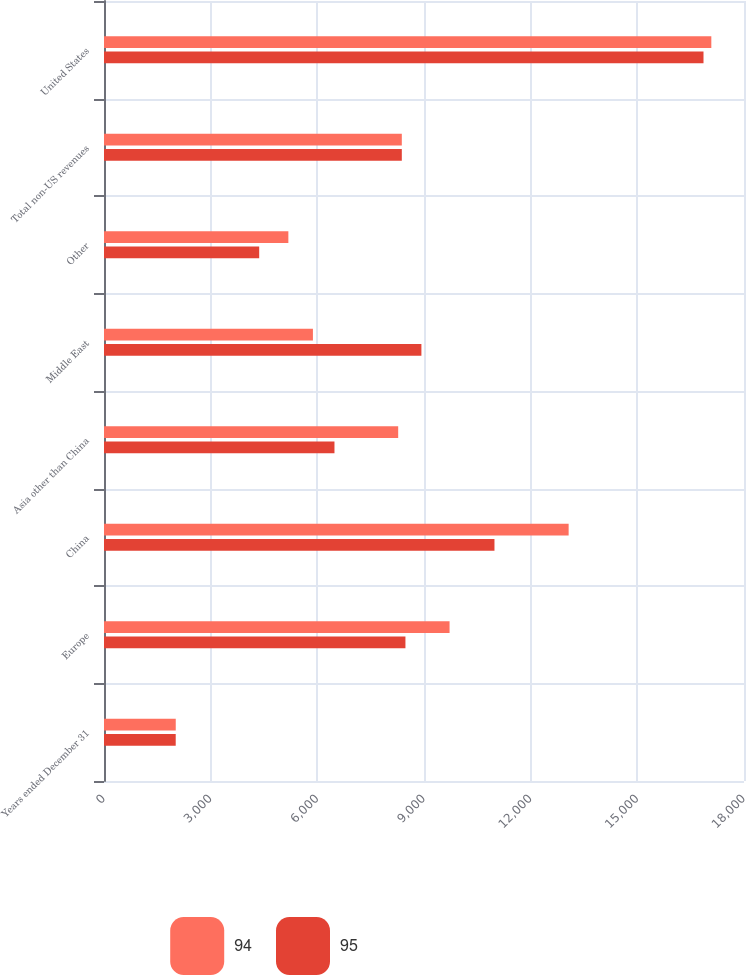Convert chart. <chart><loc_0><loc_0><loc_500><loc_500><stacked_bar_chart><ecel><fcel>Years ended December 31<fcel>Europe<fcel>China<fcel>Asia other than China<fcel>Middle East<fcel>Other<fcel>Total non-US revenues<fcel>United States<nl><fcel>94<fcel>2018<fcel>9719<fcel>13068<fcel>8274<fcel>5876<fcel>5185<fcel>8376<fcel>17081<nl><fcel>95<fcel>2017<fcel>8478<fcel>10982<fcel>6482<fcel>8927<fcel>4365<fcel>8376<fcel>16861<nl></chart> 